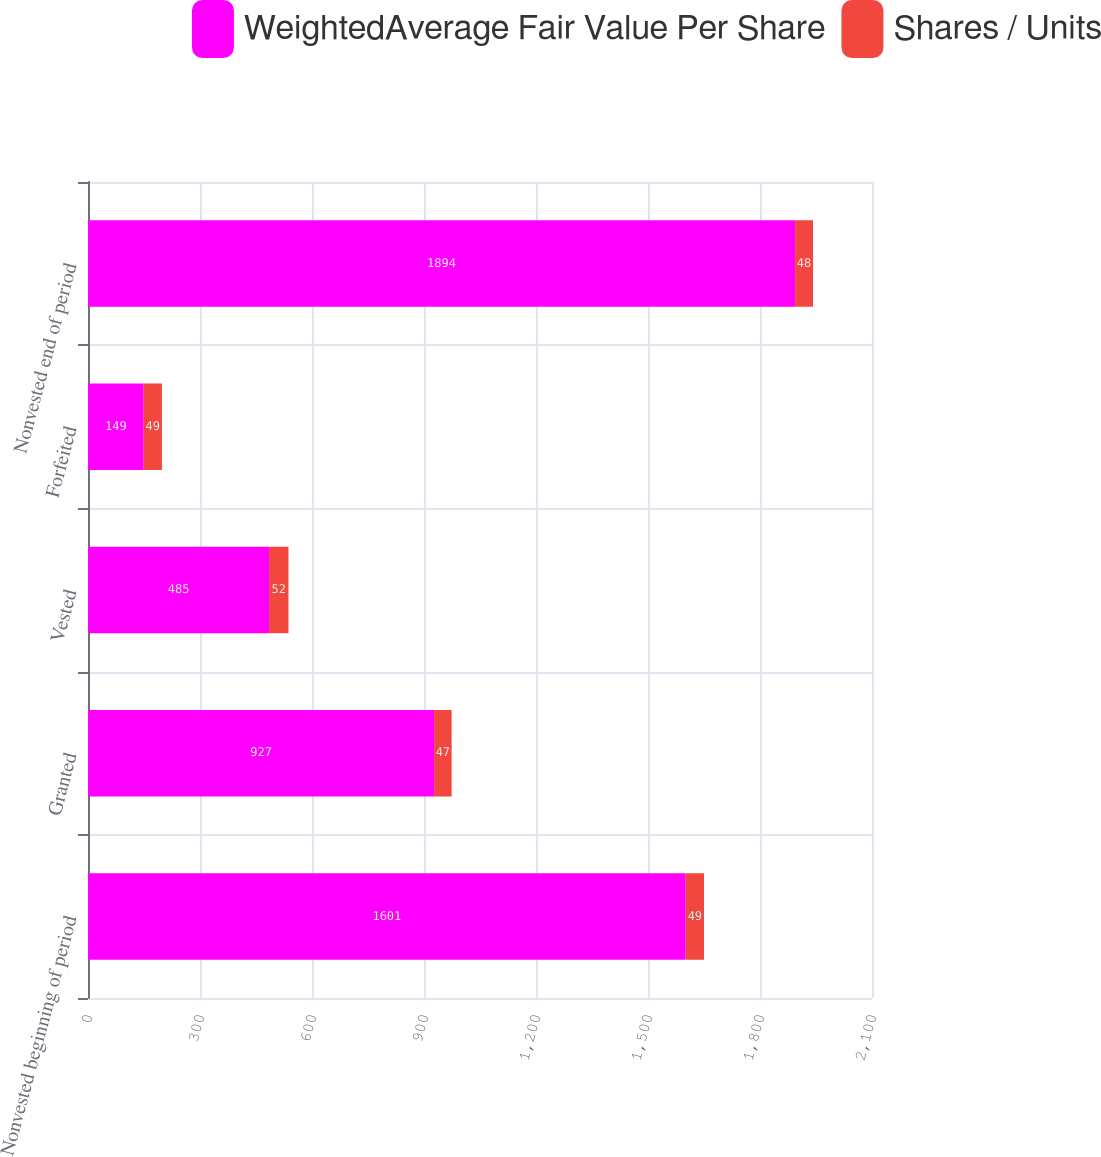Convert chart to OTSL. <chart><loc_0><loc_0><loc_500><loc_500><stacked_bar_chart><ecel><fcel>Nonvested beginning of period<fcel>Granted<fcel>Vested<fcel>Forfeited<fcel>Nonvested end of period<nl><fcel>WeightedAverage Fair Value Per Share<fcel>1601<fcel>927<fcel>485<fcel>149<fcel>1894<nl><fcel>Shares / Units<fcel>49<fcel>47<fcel>52<fcel>49<fcel>48<nl></chart> 